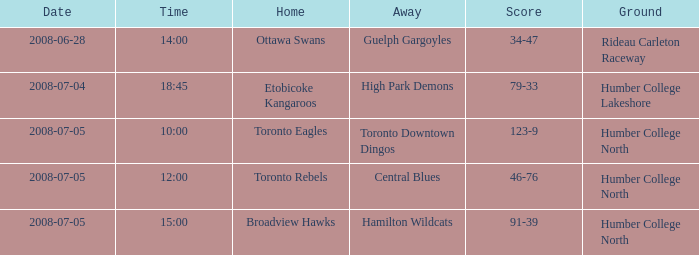What is the Date with a Time that is 18:45? 2008-07-04. 